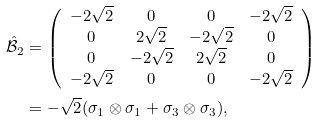Convert formula to latex. <formula><loc_0><loc_0><loc_500><loc_500>\hat { \mathcal { B } } _ { 2 } & = \left ( \begin{array} { c c c c } - 2 \sqrt { 2 } & 0 & 0 & - 2 \sqrt { 2 } \\ 0 & 2 \sqrt { 2 } & - 2 \sqrt { 2 } & 0 \\ 0 & - 2 \sqrt { 2 } & 2 \sqrt { 2 } & 0 \\ - 2 \sqrt { 2 } & 0 & 0 & - 2 \sqrt { 2 } \\ \end{array} \right ) \\ & = - \sqrt { 2 } ( \sigma _ { 1 } \otimes \sigma _ { 1 } + \sigma _ { 3 } \otimes \sigma _ { 3 } ) , \\</formula> 